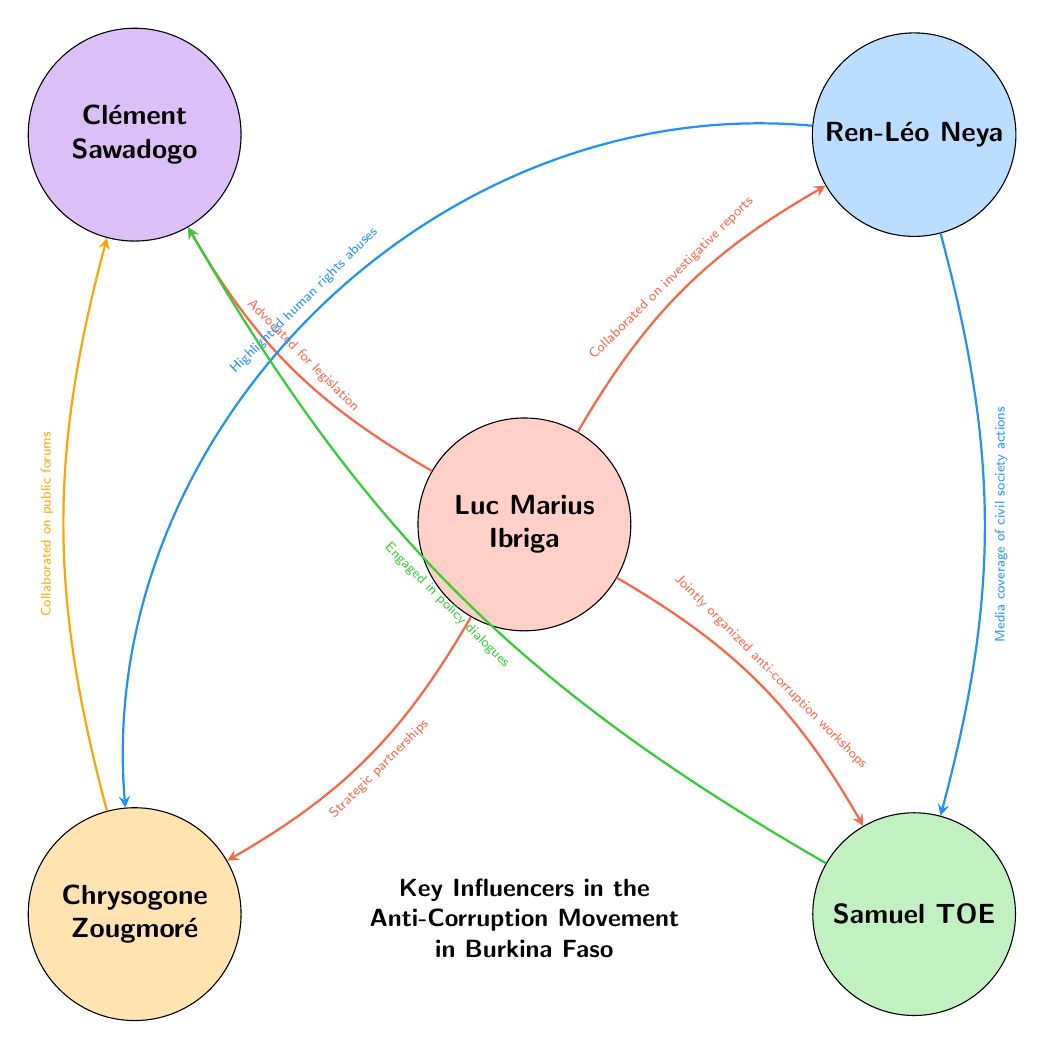What is the role of Luc Marius Ibriga? The diagram identifies Luc Marius Ibriga's role as an Anti-Corruption Expert, which is explicitly stated within his node.
Answer: Anti-Corruption Expert How many nodes are present in the diagram? By counting the individual nodes represented in the diagram, we find there are five key influencers depicted: Luc Marius Ibriga, Ren-Léo Neya, Samuel TOE, Chrysogone Zougmoré, and Clément Sawadogo.
Answer: 5 What relationship exists between Luc Marius Ibriga and Clément Sawadogo? The arrow between Luc Marius Ibriga and Clément Sawadogo specifies that he advocated for anti-corruption legislation, showing their collaborative efforts.
Answer: Advocated for anti-corruption legislation Which two individuals collaborated on public forums? The link connecting Chrysogone Zougmoré to Clément Sawadogo explicitly indicates that they collaborated on public forums, making this their key relationship.
Answer: Collaborated on public forums Who provided media coverage of civil society actions? The diagram shows that Ren-Léo Neya provided media coverage of civil society actions, establishing his role in highlighting such initiatives.
Answer: Ren-Léo Neya Which node has the most connections in the diagram? By analyzing the connections, we see that Luc Marius Ibriga has four outgoing links to other nodes, making him the most connected influencer in this diagram.
Answer: Luc Marius Ibriga What type of activists does Samuel TOE represent? The node associated with Samuel TOE identifies him as a Civil Society Activist, indicating his role in the anti-corruption movement.
Answer: Civil Society Activist How many relationships involve Chrysogone Zougmoré? Examining the arrows emanating from Chrysogone Zougmoré's node, we find two outgoing relationships — one to Clément Sawadogo and one to Ren-Léo Neya.
Answer: 2 Which two individuals have a relationship concerning anti-corruption workshops? The arrow originating from Luc Marius Ibriga leading to Samuel TOE specifies that they jointly organized anti-corruption workshops, defining their collaborative efforts.
Answer: Jointly organized anti-corruption workshops 